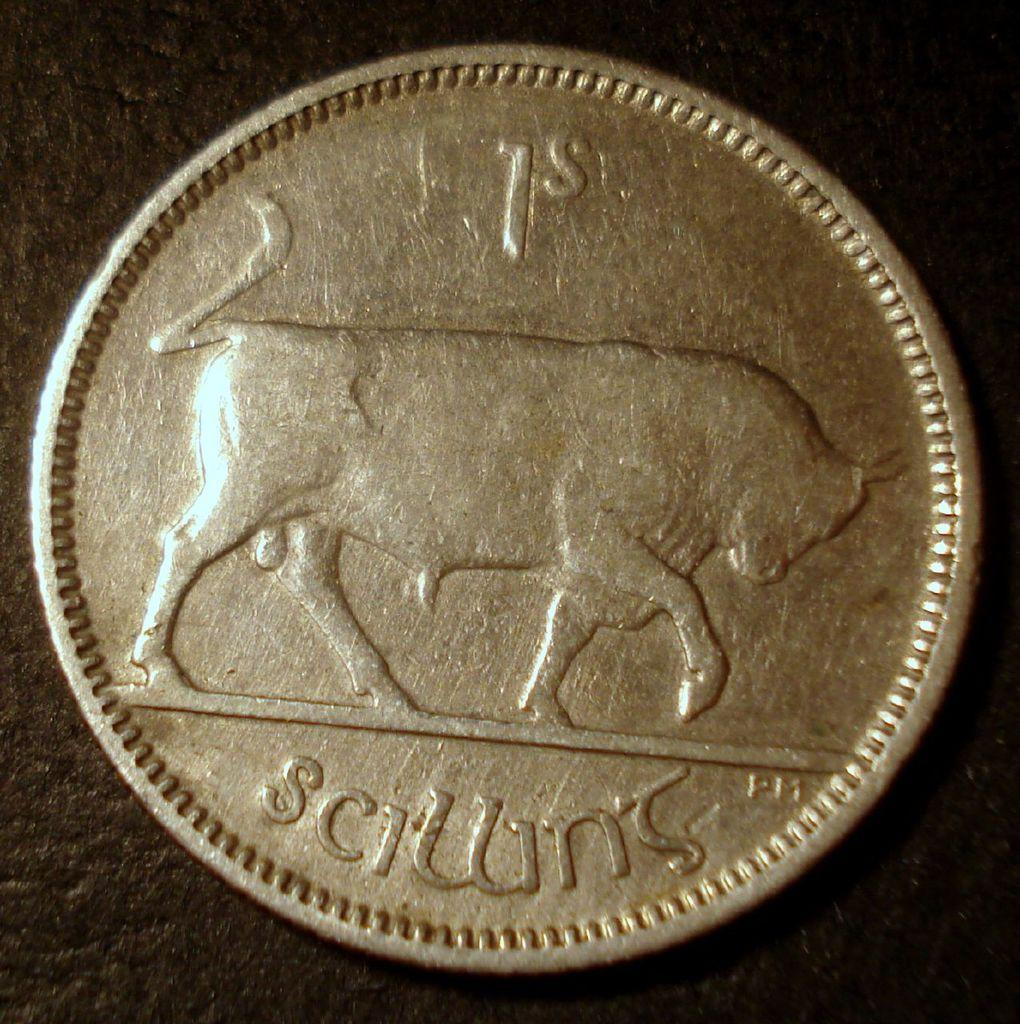<image>
Render a clear and concise summary of the photo. A coin with a bull on it says 1s. 